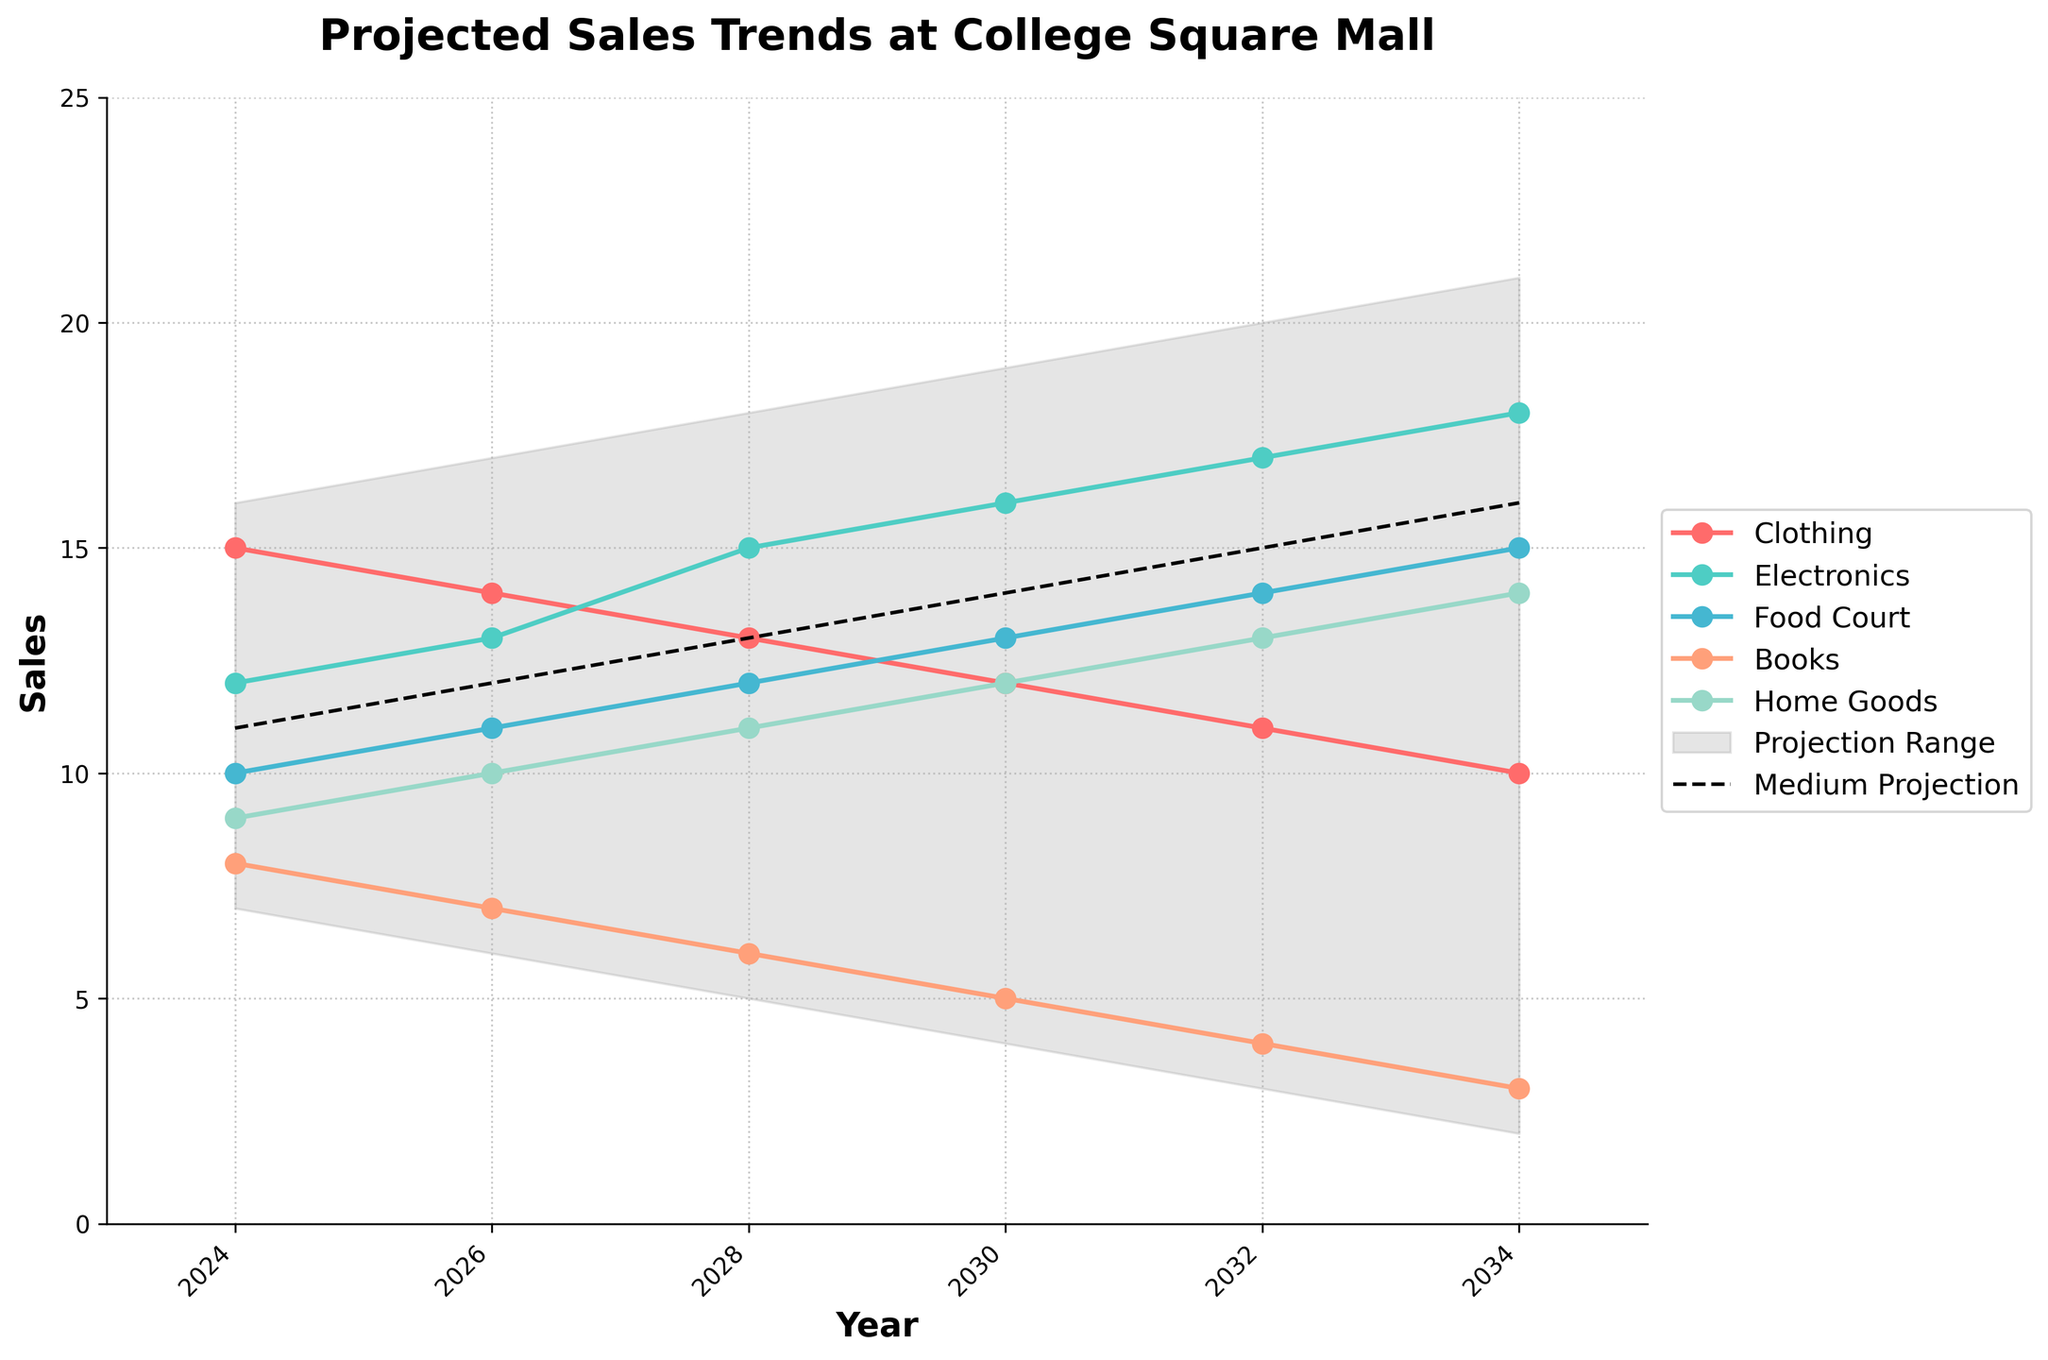When do the projected sales trends start according to the figure? The x-axis labeled 'Year' starts from 2024. Thus, the projected sales trends start in 2024.
Answer: 2024 Which store category has the highest projected sales in 2034? By looking at the data points in 2034, Electronics has the highest projected sales at 18 units.
Answer: Electronics What is the overall trend for Bookstore sales over the years? By examining the 'Books' line, it shows a declining trend from 8 units in 2024 to 3 units in 2034.
Answer: Decline Using the medium projection, what is the expected sales figure in 2028? The medium projection line, marked with black dashes, shows the sales figure in 2028 to be 13.
Answer: 13 How does the trend for Food Court compare to Home Goods over the decade? By observing both lines, the Food Court shows a steady incline from 10 to 15 while Home Goods shows a steady incline from 9 to 14. Thus, both are increasing, but Food Court starts and ends slightly higher.
Answer: Both increase, Food Court higher In what year are Clothing sales projected to drop below 12 units? By following the Clothing sales line, it drops to below 12 units in 2030.
Answer: 2030 What's the total difference between the highest and lowest estimated values in the year 2030? The highest estimate in 2030 is 19 and the lowest is 4, so the difference is 19 - 4, which equals 15.
Answer: 15 Between which consecutive years is the sharpest decline in Food Court sales projected to occur? Comparing the drops between years, the sharpest decline for Food Court is between 2028 and 2030, where sales drop from 12 to 5, i.e., a 7-unit drop.
Answer: 2028 to 2030 What type of visual indicates the variability in the sales projections? The shaded area between the 'Low' and 'High' projection lines indicates the range of variability in the sales projections.
Answer: Shaded area How many projections lines are presented in the figure for each store category? For each category, there is one line representing the sales projections over time.
Answer: 1 per category 